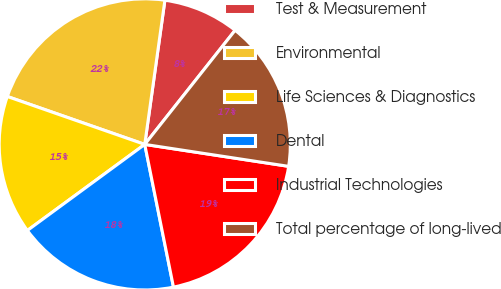<chart> <loc_0><loc_0><loc_500><loc_500><pie_chart><fcel>Test & Measurement<fcel>Environmental<fcel>Life Sciences & Diagnostics<fcel>Dental<fcel>Industrial Technologies<fcel>Total percentage of long-lived<nl><fcel>8.45%<fcel>21.87%<fcel>15.41%<fcel>18.09%<fcel>19.43%<fcel>16.75%<nl></chart> 